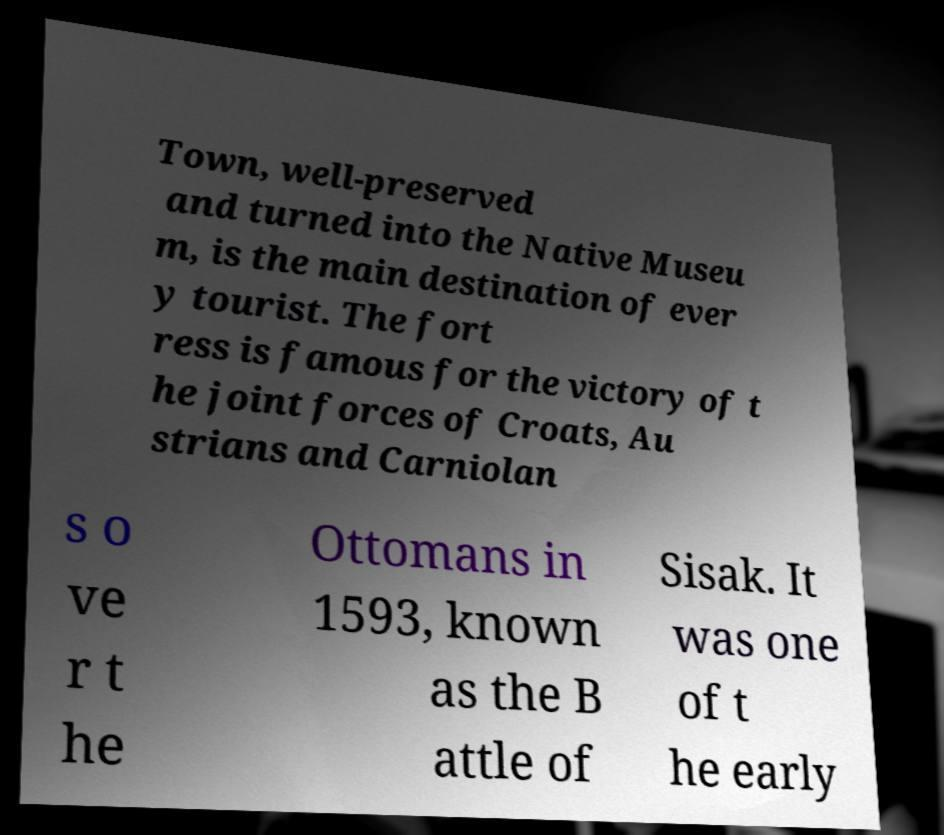For documentation purposes, I need the text within this image transcribed. Could you provide that? Town, well-preserved and turned into the Native Museu m, is the main destination of ever y tourist. The fort ress is famous for the victory of t he joint forces of Croats, Au strians and Carniolan s o ve r t he Ottomans in 1593, known as the B attle of Sisak. It was one of t he early 